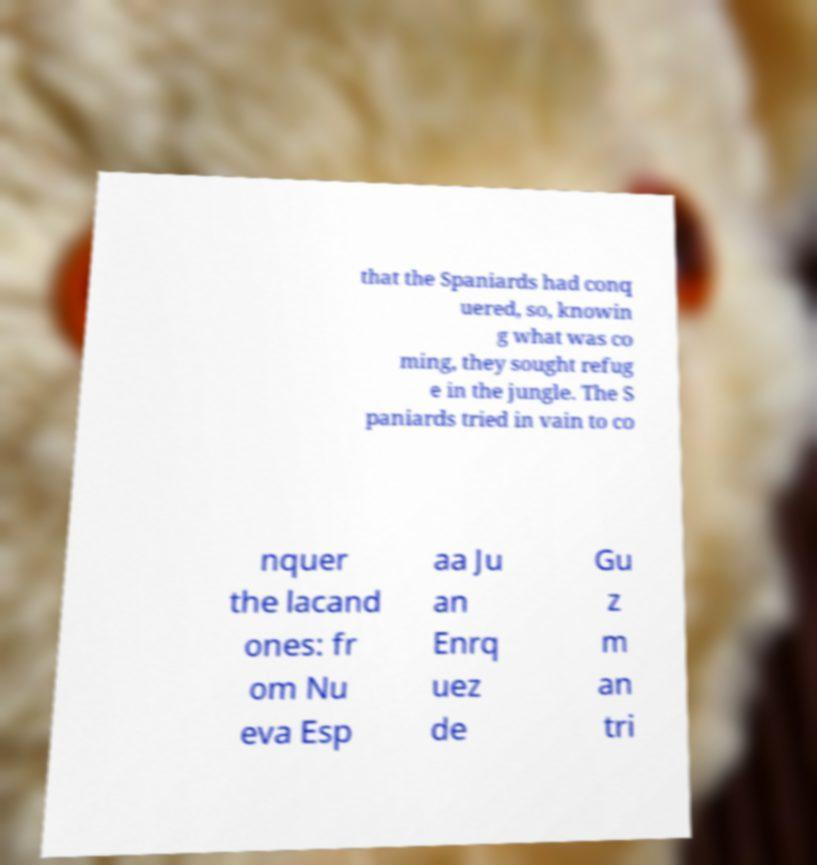For documentation purposes, I need the text within this image transcribed. Could you provide that? that the Spaniards had conq uered, so, knowin g what was co ming, they sought refug e in the jungle. The S paniards tried in vain to co nquer the lacand ones: fr om Nu eva Esp aa Ju an Enrq uez de Gu z m an tri 